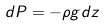Convert formula to latex. <formula><loc_0><loc_0><loc_500><loc_500>d P = - \rho g d z</formula> 